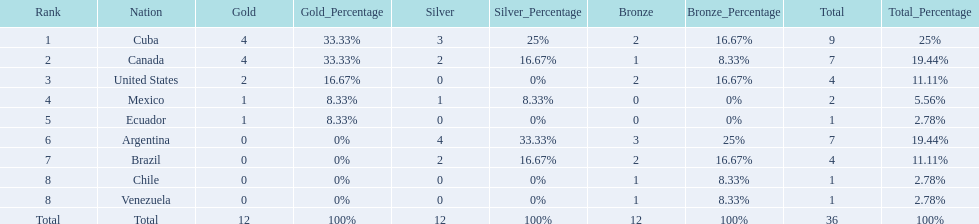Which countries have won gold medals? Cuba, Canada, United States, Mexico, Ecuador. Of these countries, which ones have never won silver or bronze medals? United States, Ecuador. Of the two nations listed previously, which one has only won a gold medal? Ecuador. 